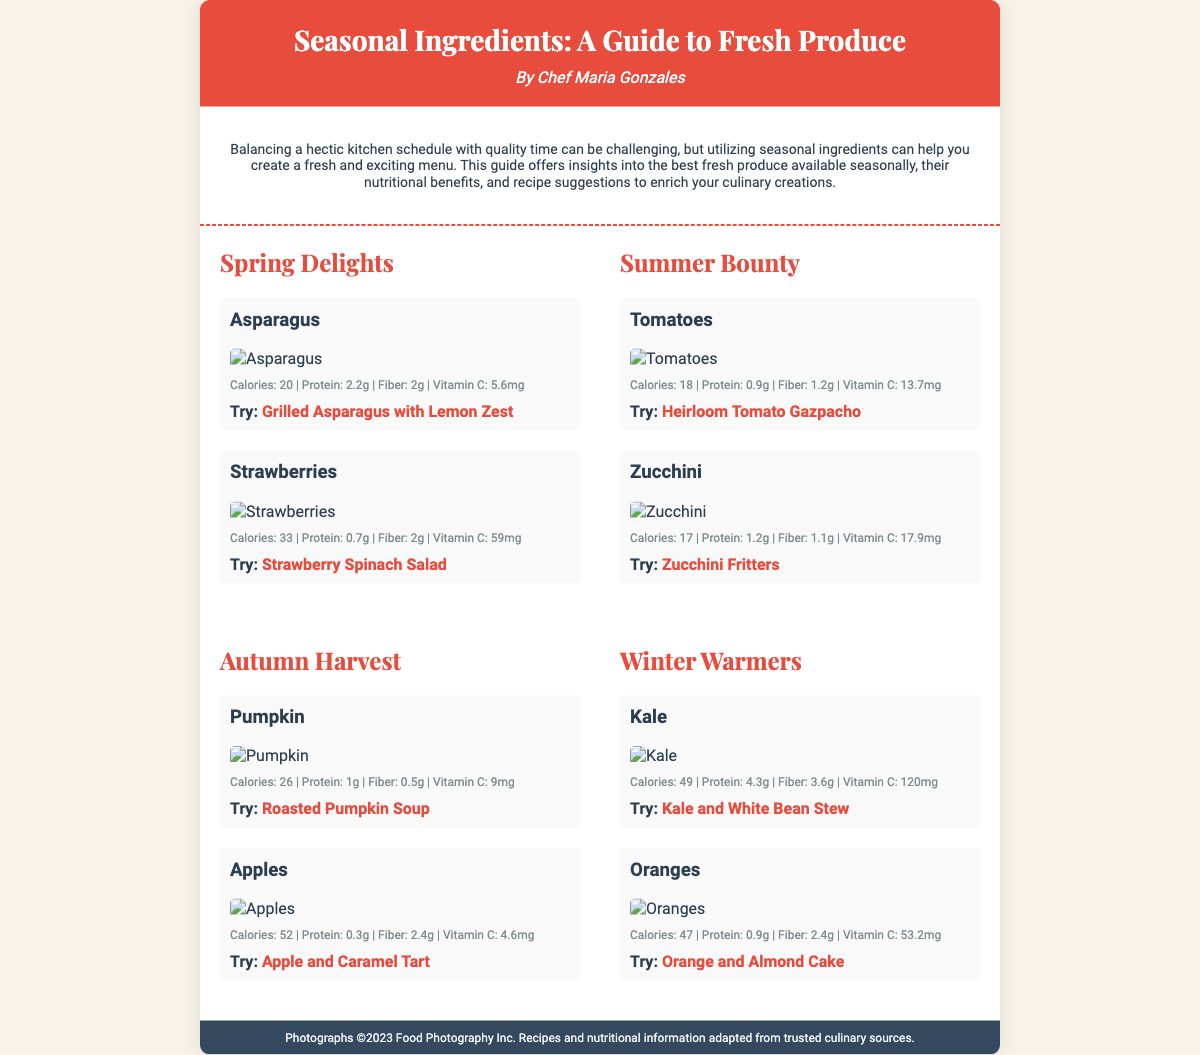What is the title of the guide? The title of the guide is prominently displayed at the top of the document, indicating the main subject of the content.
Answer: Seasonal Ingredients: A Guide to Fresh Produce Who is the author of the Playbill? The author's name is listed directly below the title, indicating who wrote the guide.
Answer: Chef Maria Gonzales What season do strawberries belong to? Strawberries are listed under the section for spring, indicating their seasonal availability.
Answer: Spring How many calories are in zucchini? The nutritional information for zucchini is provided in the document, specifying its calorie content.
Answer: 17 What is the suggested recipe for kale? The recipe suggestion for kale is mentioned in the corresponding section about this ingredient.
Answer: Kale and White Bean Stew Which fruit is mentioned alongside oranges in the winter section? The document lists the ingredients for winter, and oranges are paired with another ingredient.
Answer: Kale What is the protein content of pumpkin? The nutritional information is provided, detailing the protein content for pumpkin.
Answer: 1g What unique challenge does the guide address? The introduction states the primary issue that the guide seeks to help chefs solve.
Answer: Balancing a hectic kitchen schedule with quality time 